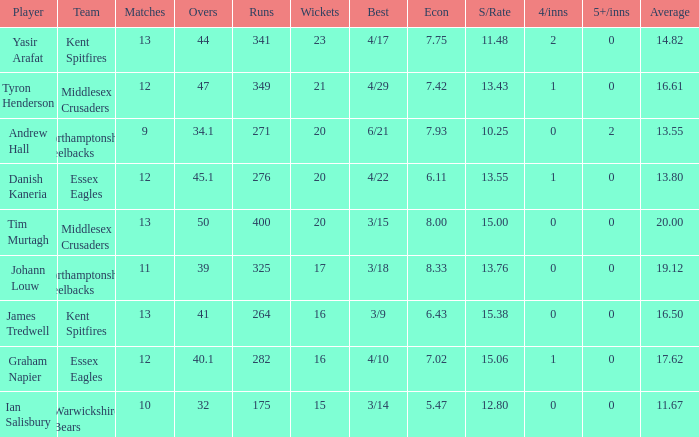Name the most 4/inns 2.0. 